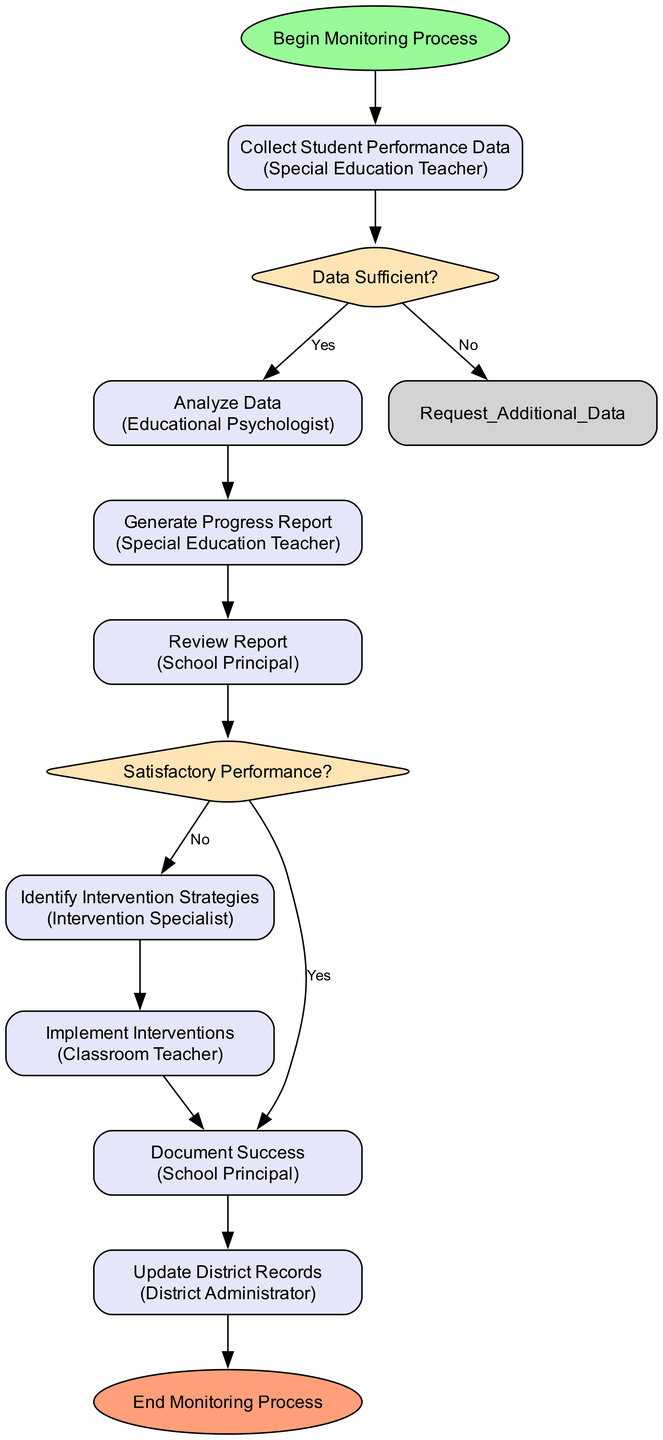What is the first activity in the workflow? The first activity is labeled as "Collect Student Performance Data" and is directly connected to the starting point "Begin Monitoring Process."
Answer: Collect Student Performance Data Who is responsible for analyzing the data? The node for "Analyze Data" clearly states that it is the responsibility of the "Educational Psychologist."
Answer: Educational Psychologist How many decision points are present in the diagram? The diagram contains two decision points: "Data Sufficient?" and "Satisfactory Performance?" Thus, counting these gives us a total of two decision points.
Answer: 2 What activity follows after the "Review Report"? The "Review Report" is followed by the decision point "Satisfactory Performance?" which makes it the next step in the workflow.
Answer: Satisfactory Performance? If "Data Sufficient?" branch is "No," what is the subsequent activity? If the decision "Data Sufficient?" is "No," the flow goes to the activity "Request Additional Data," according to the diagram logic.
Answer: Request Additional Data What does "Identify Intervention Strategies" lead to? After "Identify Intervention Strategies," the next activity in the flow is "Implement Interventions," showing a direct connection between these two nodes.
Answer: Implement Interventions How is the "Document Success" activity linked to the workflow? The "Document Success" activity follows the decision point "Satisfactory Performance?" where if the performance is satisfactory, it directs the flow to this documentation task.
Answer: Document Success Who updates the district records? The node labeled "Update District Records" identifies the responsible party as the "District Administrator."
Answer: District Administrator What is the final step in the monitoring process? The last node in the diagram is "End Monitoring Process," which indicates the conclusion of the workflow.
Answer: End Monitoring Process 